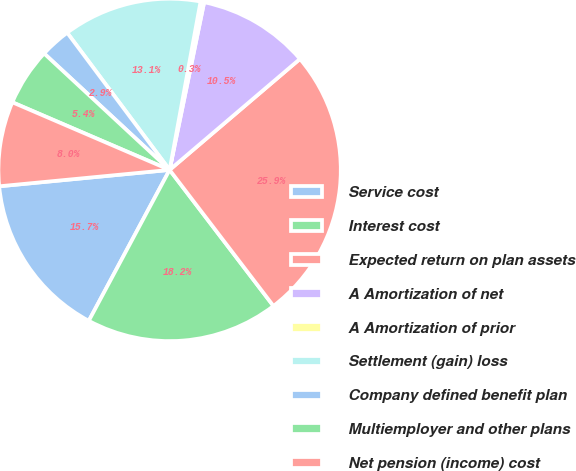<chart> <loc_0><loc_0><loc_500><loc_500><pie_chart><fcel>Service cost<fcel>Interest cost<fcel>Expected return on plan assets<fcel>A Amortization of net<fcel>A Amortization of prior<fcel>Settlement (gain) loss<fcel>Company defined benefit plan<fcel>Multiemployer and other plans<fcel>Net pension (income) cost<nl><fcel>15.65%<fcel>18.2%<fcel>25.85%<fcel>10.54%<fcel>0.34%<fcel>13.1%<fcel>2.89%<fcel>5.44%<fcel>7.99%<nl></chart> 